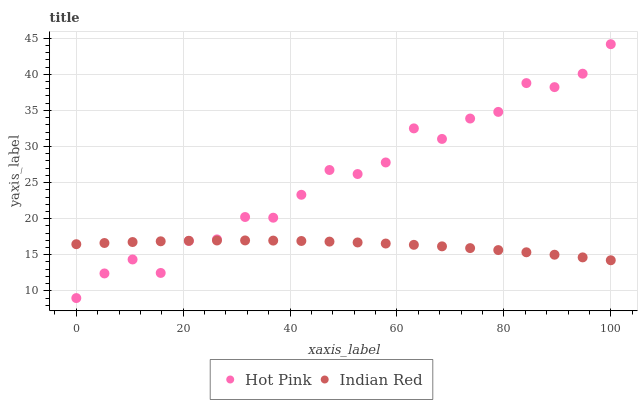Does Indian Red have the minimum area under the curve?
Answer yes or no. Yes. Does Hot Pink have the maximum area under the curve?
Answer yes or no. Yes. Does Indian Red have the maximum area under the curve?
Answer yes or no. No. Is Indian Red the smoothest?
Answer yes or no. Yes. Is Hot Pink the roughest?
Answer yes or no. Yes. Is Indian Red the roughest?
Answer yes or no. No. Does Hot Pink have the lowest value?
Answer yes or no. Yes. Does Indian Red have the lowest value?
Answer yes or no. No. Does Hot Pink have the highest value?
Answer yes or no. Yes. Does Indian Red have the highest value?
Answer yes or no. No. Does Hot Pink intersect Indian Red?
Answer yes or no. Yes. Is Hot Pink less than Indian Red?
Answer yes or no. No. Is Hot Pink greater than Indian Red?
Answer yes or no. No. 